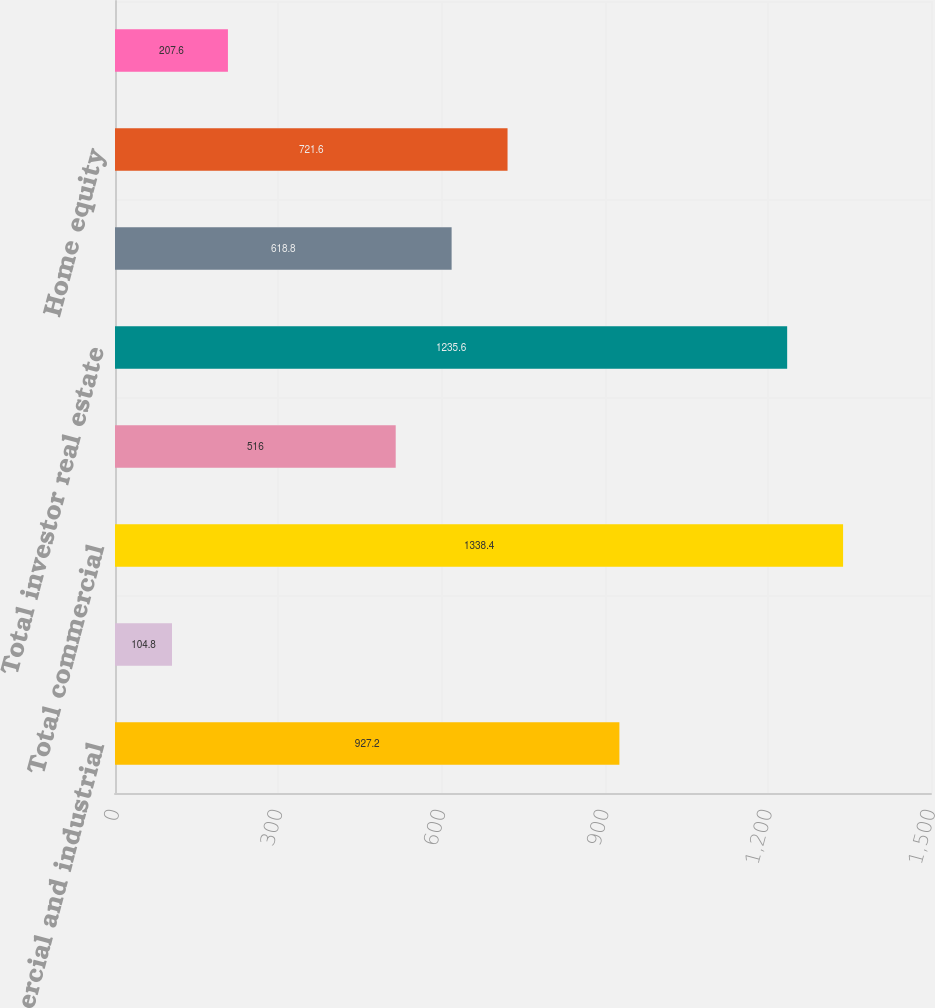Convert chart to OTSL. <chart><loc_0><loc_0><loc_500><loc_500><bar_chart><fcel>Commercial and industrial<fcel>Commercial real estate<fcel>Total commercial<fcel>Commercial investor real<fcel>Total investor real estate<fcel>Residential first mortgage<fcel>Home equity<fcel>Indirect-vehicles<nl><fcel>927.2<fcel>104.8<fcel>1338.4<fcel>516<fcel>1235.6<fcel>618.8<fcel>721.6<fcel>207.6<nl></chart> 